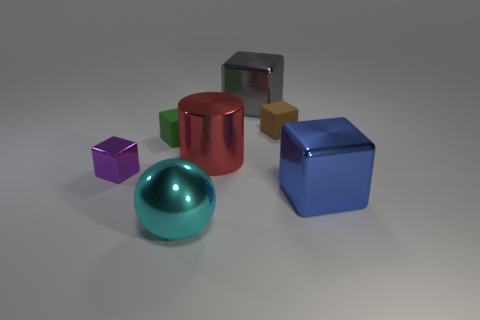Subtract all purple cubes. How many cubes are left? 4 Subtract all blue blocks. How many blocks are left? 4 Add 2 tiny brown cylinders. How many objects exist? 9 Subtract all blue cubes. Subtract all brown balls. How many cubes are left? 4 Subtract all spheres. How many objects are left? 6 Subtract all big purple cubes. Subtract all small matte things. How many objects are left? 5 Add 1 big red cylinders. How many big red cylinders are left? 2 Add 3 purple metallic objects. How many purple metallic objects exist? 4 Subtract 0 blue cylinders. How many objects are left? 7 